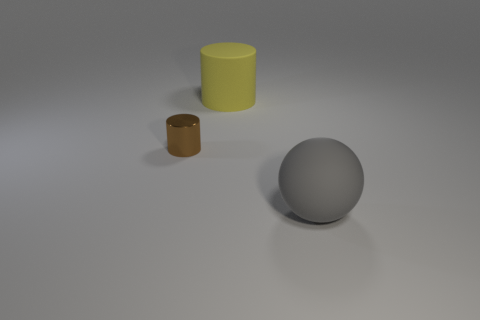What is the material of the cylinder that is in front of the large thing that is to the left of the large gray sphere?
Your response must be concise. Metal. Do the tiny cylinder and the big thing on the left side of the large gray sphere have the same material?
Offer a terse response. No. The thing that is both in front of the large yellow cylinder and behind the big gray sphere is made of what material?
Keep it short and to the point. Metal. There is a cylinder in front of the yellow cylinder; what is it made of?
Provide a short and direct response. Metal. Is the shape of the small shiny object the same as the big rubber object behind the big gray sphere?
Your response must be concise. Yes. There is a object that is both in front of the big yellow rubber cylinder and on the left side of the sphere; what shape is it?
Your answer should be very brief. Cylinder. Are there an equal number of large yellow things in front of the brown metallic cylinder and big yellow matte cylinders left of the yellow cylinder?
Offer a terse response. Yes. Is the shape of the thing that is on the left side of the yellow rubber cylinder the same as  the yellow thing?
Keep it short and to the point. Yes. How many gray things are either cylinders or small metal things?
Offer a very short reply. 0. There is a large yellow object that is the same shape as the tiny metallic thing; what is its material?
Ensure brevity in your answer.  Rubber. 